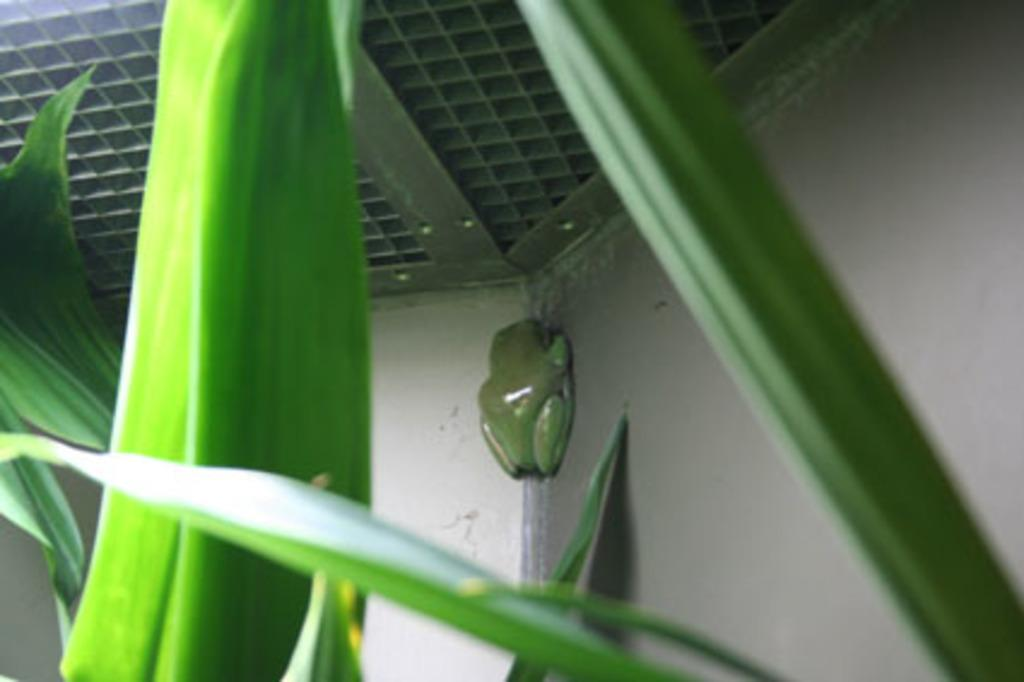What is covering the front of the image? There are leaves in front of the image. What can be seen on the wall in the image? There is an object on the wall. What type of roof is visible at the top of the image? There is a metal roof at the top of the image. What type of arch can be seen in the image? There is no arch present in the image. What hope does the image convey? The image does not convey any specific hope or emotion; it is a static representation of the scene. 